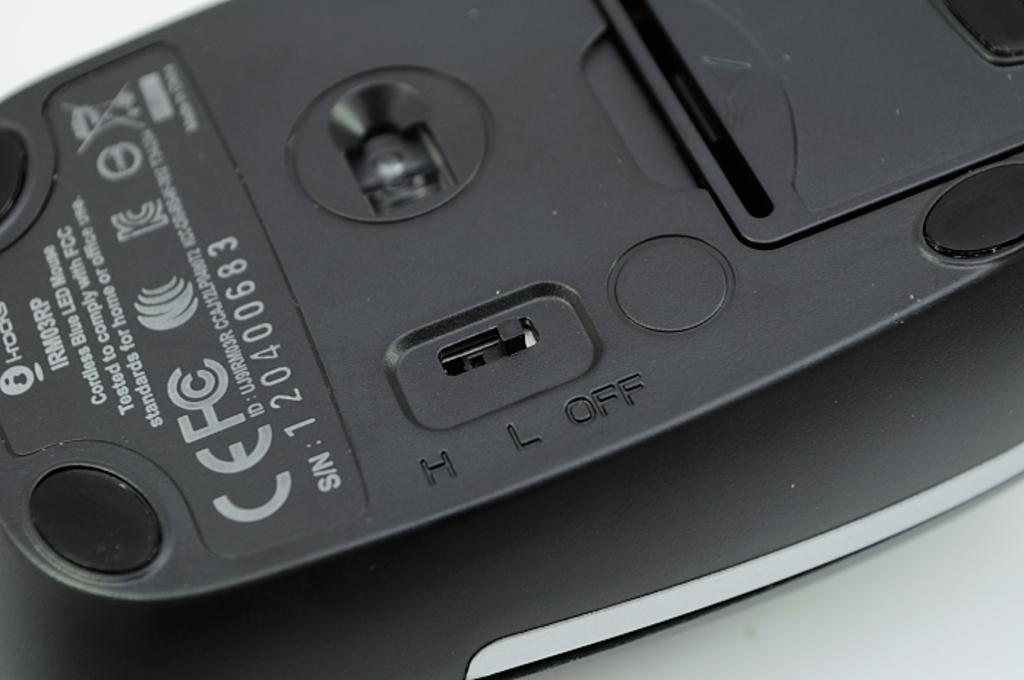<image>
Write a terse but informative summary of the picture. The back of a cordless blue LED mouse currently switched off. 